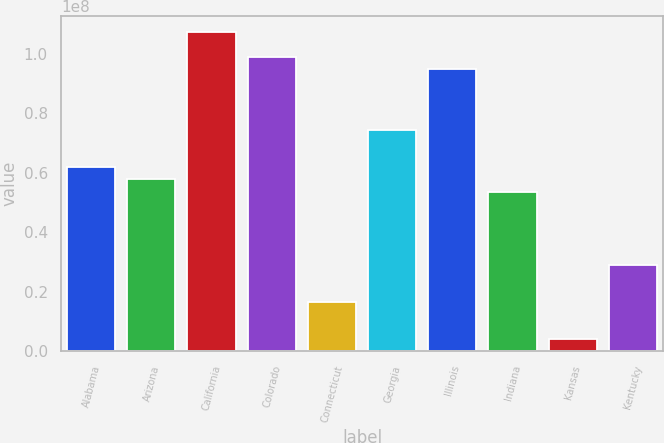<chart> <loc_0><loc_0><loc_500><loc_500><bar_chart><fcel>Alabama<fcel>Arizona<fcel>California<fcel>Colorado<fcel>Connecticut<fcel>Georgia<fcel>Illinois<fcel>Indiana<fcel>Kansas<fcel>Kentucky<nl><fcel>6.19013e+07<fcel>5.77787e+07<fcel>1.07251e+08<fcel>9.90053e+07<fcel>1.65521e+07<fcel>7.42693e+07<fcel>9.48826e+07<fcel>5.3656e+07<fcel>4.18409e+06<fcel>2.892e+07<nl></chart> 